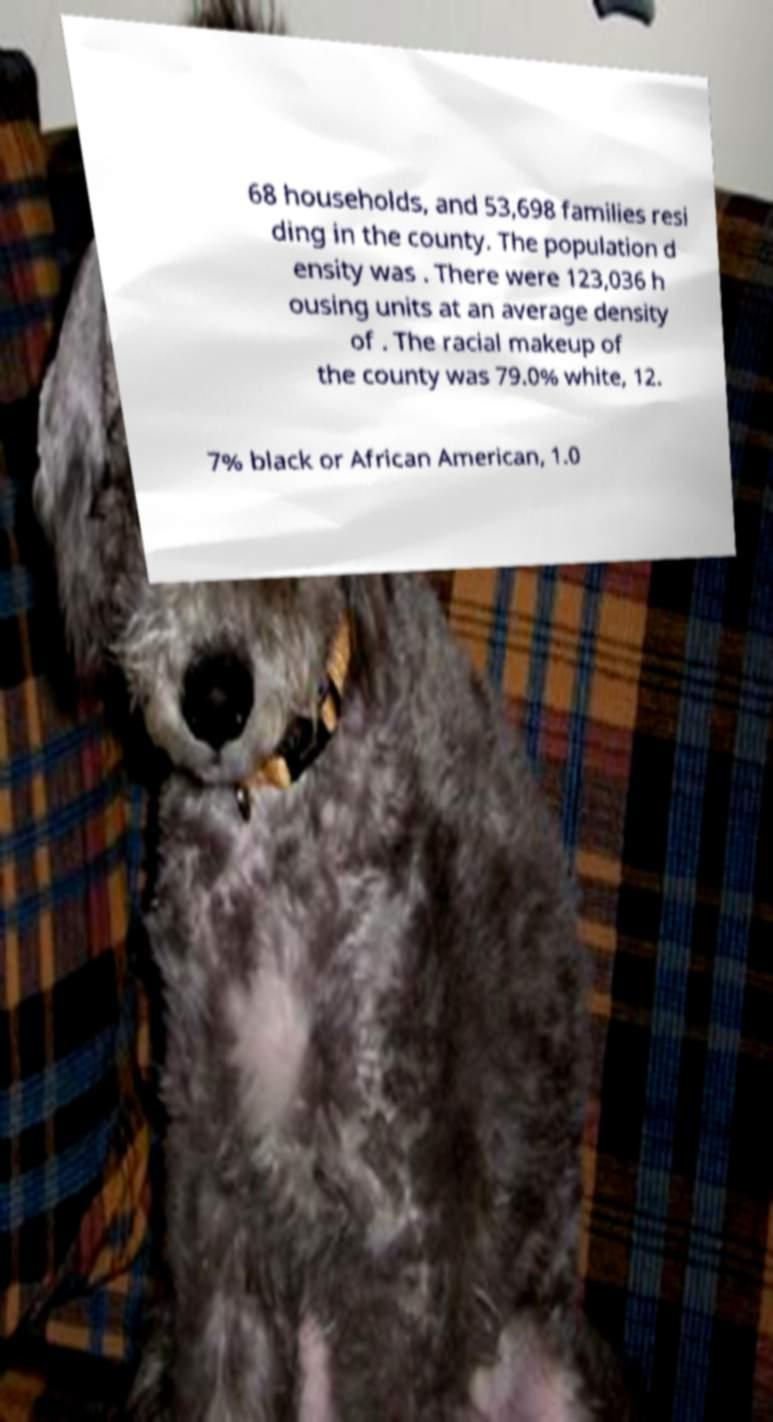Can you read and provide the text displayed in the image?This photo seems to have some interesting text. Can you extract and type it out for me? 68 households, and 53,698 families resi ding in the county. The population d ensity was . There were 123,036 h ousing units at an average density of . The racial makeup of the county was 79.0% white, 12. 7% black or African American, 1.0 